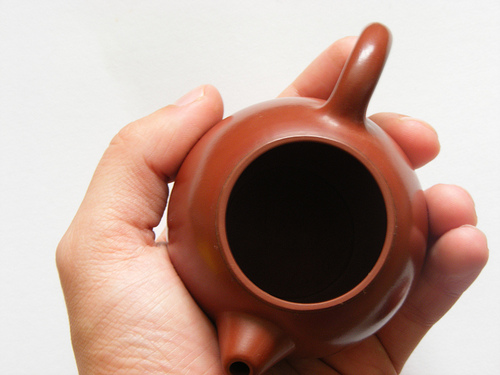<image>
Is the man hand on the pot? No. The man hand is not positioned on the pot. They may be near each other, but the man hand is not supported by or resting on top of the pot. Is the pot next to the person? Yes. The pot is positioned adjacent to the person, located nearby in the same general area. 